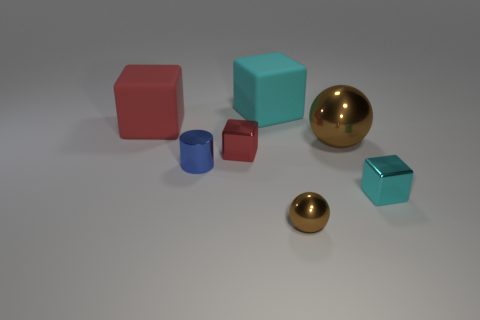There is a matte thing that is to the left of the large cyan matte cube; does it have the same shape as the brown object that is behind the small blue object?
Ensure brevity in your answer.  No. What color is the small thing that is both behind the small cyan metal thing and right of the tiny blue shiny thing?
Your answer should be compact. Red. Is the size of the cyan object behind the red matte thing the same as the brown thing that is behind the tiny red metal thing?
Keep it short and to the point. Yes. How many other tiny cylinders have the same color as the cylinder?
Provide a short and direct response. 0. What number of big things are either blue cylinders or purple cylinders?
Ensure brevity in your answer.  0. Do the cube that is in front of the small blue object and the small red object have the same material?
Provide a short and direct response. Yes. What color is the rubber thing that is on the left side of the tiny red shiny block?
Your answer should be very brief. Red. Are there any cyan rubber objects that have the same size as the red matte cube?
Provide a succinct answer. Yes. What material is the brown sphere that is the same size as the shiny cylinder?
Your answer should be compact. Metal. There is a red rubber cube; does it have the same size as the ball in front of the tiny blue thing?
Offer a terse response. No. 